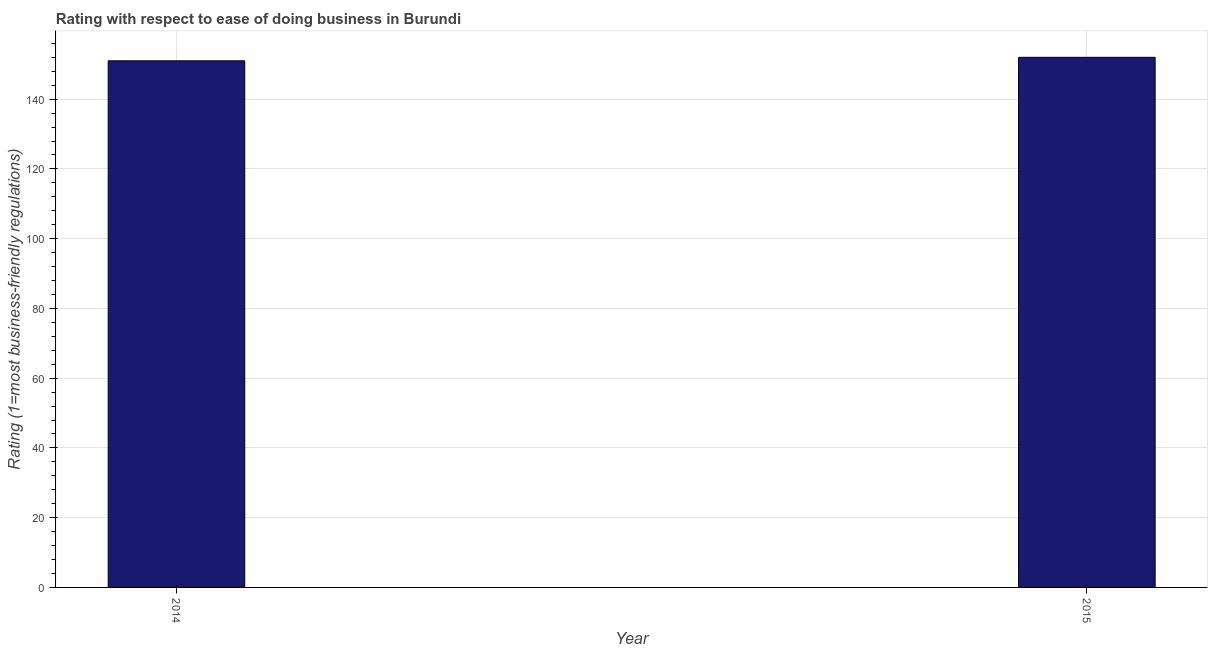Does the graph contain grids?
Provide a succinct answer. Yes. What is the title of the graph?
Your answer should be very brief. Rating with respect to ease of doing business in Burundi. What is the label or title of the Y-axis?
Give a very brief answer. Rating (1=most business-friendly regulations). What is the ease of doing business index in 2014?
Ensure brevity in your answer.  151. Across all years, what is the maximum ease of doing business index?
Offer a very short reply. 152. Across all years, what is the minimum ease of doing business index?
Provide a short and direct response. 151. In which year was the ease of doing business index maximum?
Ensure brevity in your answer.  2015. In which year was the ease of doing business index minimum?
Ensure brevity in your answer.  2014. What is the sum of the ease of doing business index?
Keep it short and to the point. 303. What is the difference between the ease of doing business index in 2014 and 2015?
Give a very brief answer. -1. What is the average ease of doing business index per year?
Make the answer very short. 151. What is the median ease of doing business index?
Your response must be concise. 151.5. How many bars are there?
Your answer should be very brief. 2. Are all the bars in the graph horizontal?
Keep it short and to the point. No. How many years are there in the graph?
Ensure brevity in your answer.  2. What is the difference between two consecutive major ticks on the Y-axis?
Your response must be concise. 20. What is the Rating (1=most business-friendly regulations) in 2014?
Provide a short and direct response. 151. What is the Rating (1=most business-friendly regulations) in 2015?
Ensure brevity in your answer.  152. What is the difference between the Rating (1=most business-friendly regulations) in 2014 and 2015?
Your answer should be very brief. -1. 